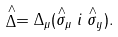Convert formula to latex. <formula><loc_0><loc_0><loc_500><loc_500>\stackrel { \wedge } { \Delta } = \Delta _ { \mu } ( \stackrel { \wedge } { \sigma } _ { \mu } i \stackrel { \wedge } { \sigma } _ { y } ) .</formula> 